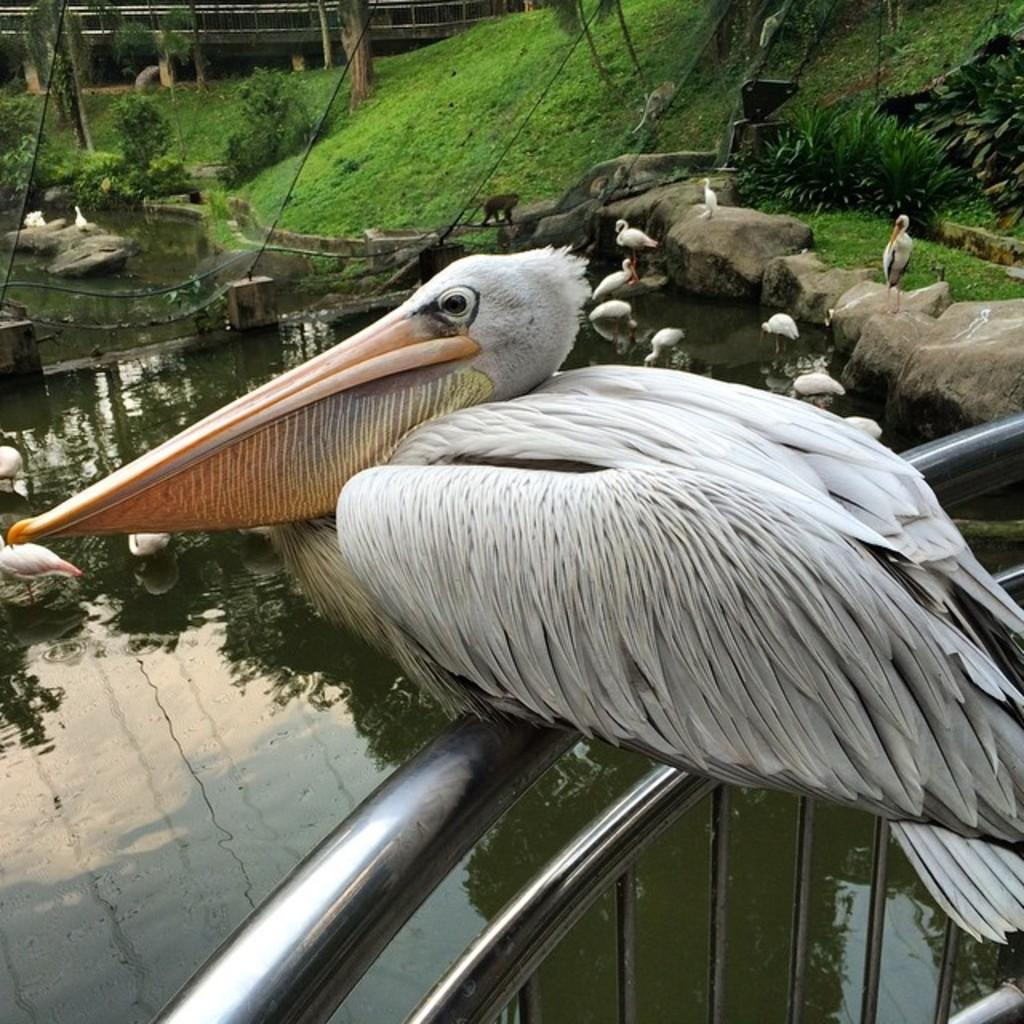What is the main subject of the image? The main subject of the image is a bird on a railing. What type of environment is depicted in the image? The image shows a natural environment with stones, water, grass, and plants visible. Are there any other animals visible in the image? Yes, there are animals visible in the image, including the bird on the railing. What objects can be seen in the image? There are some objects visible in the image, but their specific nature is not mentioned in the provided facts. What type of waste can be seen floating in the water in the image? There is no waste visible in the water in the image. Can you tell me how the bird is preparing to start its journey to space in the image? The image does not depict the bird preparing for a journey to space; it is simply perched on a railing. 